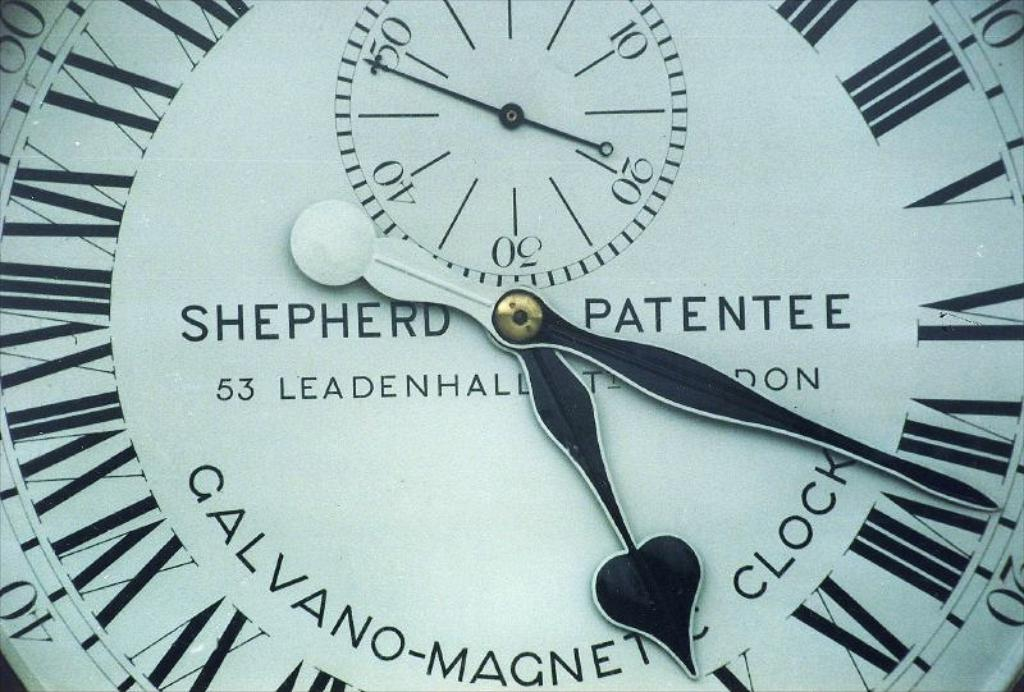Provide a one-sentence caption for the provided image. The image showcases a detailed vintage Shepherd Patentee clock face, featuring a distinctive design, located at 53 Leadenhall in London, known for its precision in timekeeping and historical significance in clockmaking. 